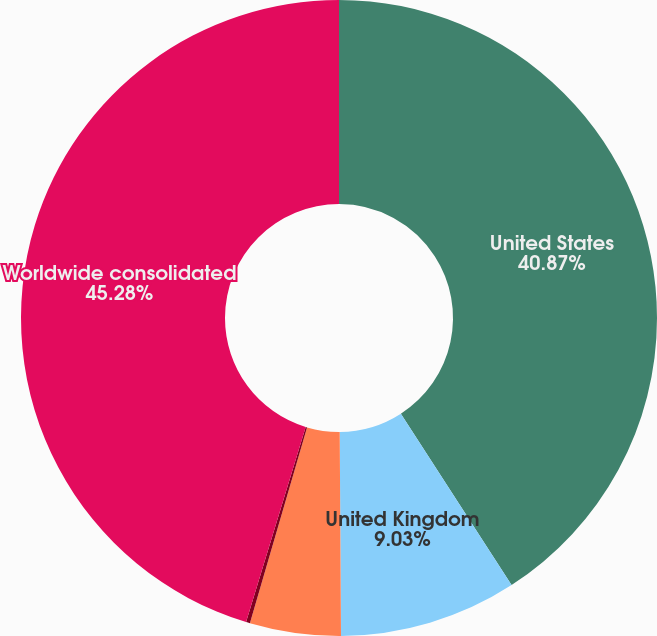<chart> <loc_0><loc_0><loc_500><loc_500><pie_chart><fcel>United States<fcel>United Kingdom<fcel>Germany<fcel>Other foreign countries<fcel>Worldwide consolidated<nl><fcel>40.87%<fcel>9.03%<fcel>4.62%<fcel>0.2%<fcel>45.28%<nl></chart> 